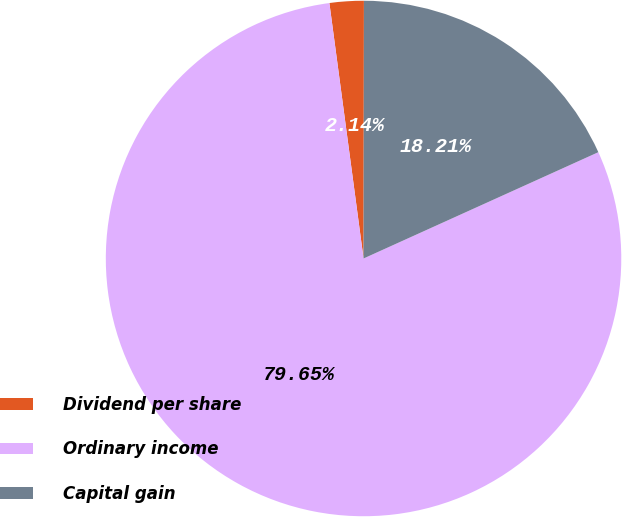<chart> <loc_0><loc_0><loc_500><loc_500><pie_chart><fcel>Dividend per share<fcel>Ordinary income<fcel>Capital gain<nl><fcel>2.14%<fcel>79.65%<fcel>18.21%<nl></chart> 